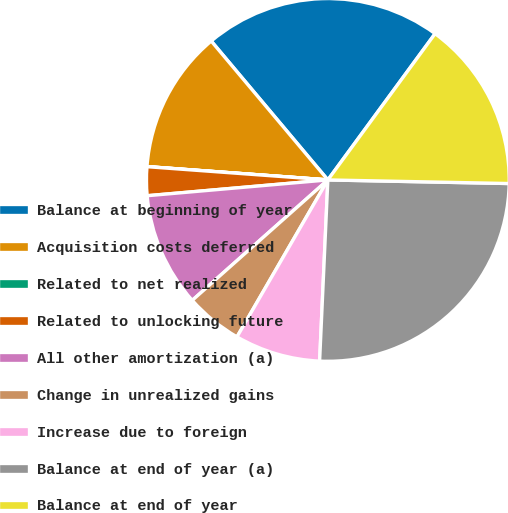Convert chart to OTSL. <chart><loc_0><loc_0><loc_500><loc_500><pie_chart><fcel>Balance at beginning of year<fcel>Acquisition costs deferred<fcel>Related to net realized<fcel>Related to unlocking future<fcel>All other amortization (a)<fcel>Change in unrealized gains<fcel>Increase due to foreign<fcel>Balance at end of year (a)<fcel>Balance at end of year<nl><fcel>21.19%<fcel>12.71%<fcel>0.01%<fcel>2.55%<fcel>10.17%<fcel>5.09%<fcel>7.63%<fcel>25.41%<fcel>15.25%<nl></chart> 